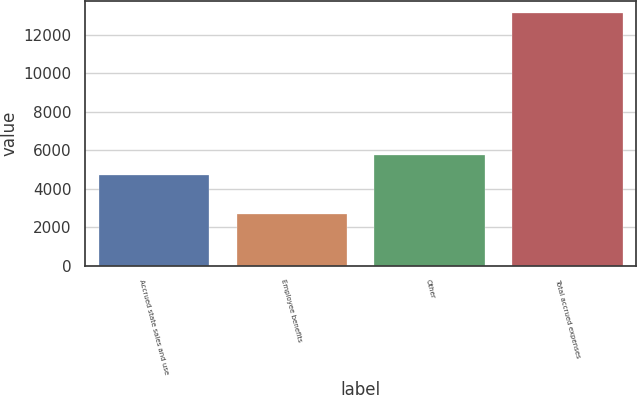Convert chart to OTSL. <chart><loc_0><loc_0><loc_500><loc_500><bar_chart><fcel>Accrued state sales and use<fcel>Employee benefits<fcel>Other<fcel>Total accrued expenses<nl><fcel>4736<fcel>2709<fcel>5778.2<fcel>13131<nl></chart> 